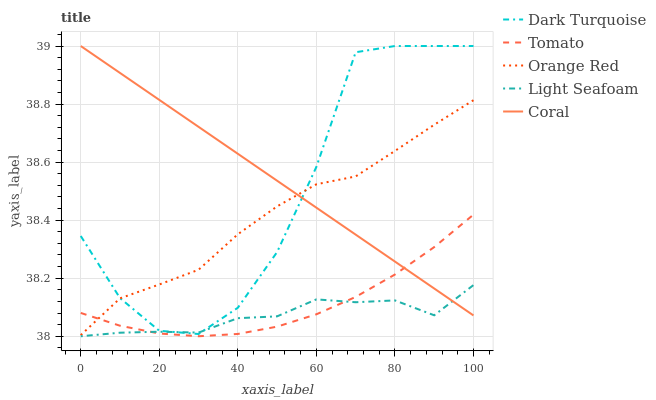Does Dark Turquoise have the minimum area under the curve?
Answer yes or no. No. Does Dark Turquoise have the maximum area under the curve?
Answer yes or no. No. Is Dark Turquoise the smoothest?
Answer yes or no. No. Is Coral the roughest?
Answer yes or no. No. Does Dark Turquoise have the lowest value?
Answer yes or no. No. Does Light Seafoam have the highest value?
Answer yes or no. No. Is Tomato less than Dark Turquoise?
Answer yes or no. Yes. Is Orange Red greater than Light Seafoam?
Answer yes or no. Yes. Does Tomato intersect Dark Turquoise?
Answer yes or no. No. 